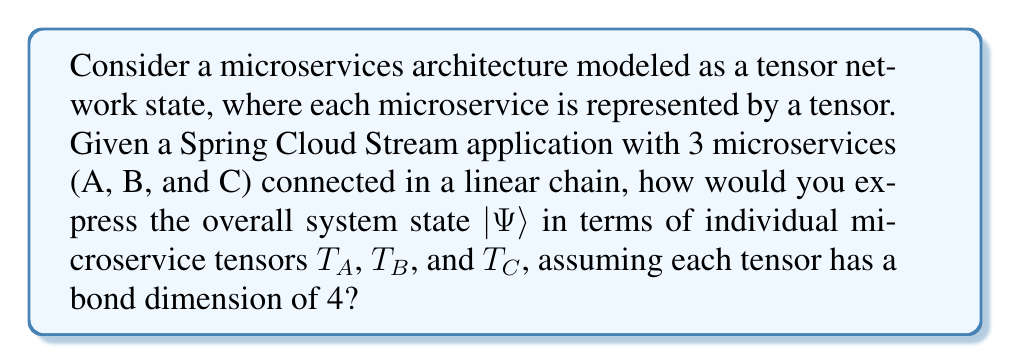Could you help me with this problem? To solve this problem, we'll follow these steps:

1. Understand the tensor network representation:
   Each microservice is represented by a tensor, and the connections between them are represented by contracted indices.

2. Identify the structure of the linear chain:
   A -> B -> C

3. Define the tensor dimensions:
   - $T_A$: 4 x 4 tensor (output dimension)
   - $T_B$: 4 x 4 x 4 tensor (input and output dimensions)
   - $T_C$: 4 x 4 tensor (input dimension)

4. Express the system state using tensor contraction:
   The overall system state $|\Psi\rangle$ is obtained by contracting the indices connecting the tensors:

   $$|\Psi\rangle = \sum_{i,j=1}^4 (T_A)_i (T_B)_{ijk} (T_C)_k$$

   Where $i$, $j$, and $k$ are the indices being summed over, representing the connections between the microservices.

5. Write the expression in Einstein notation:
   $$|\Psi\rangle = T_A^i T_B^{ijk} T_C^k$$

   This notation implicitly assumes summation over repeated indices.

6. Interpret the result:
   This expression represents how messages flow through the microservices, with each tensor capturing the transformation of data as it passes through that service.
Answer: $|\Psi\rangle = T_A^i T_B^{ijk} T_C^k$ 